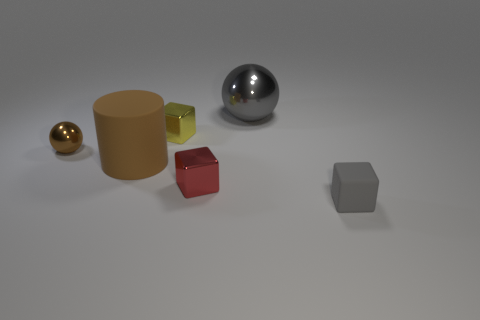How many objects are there and can you describe their colors? There are five objects in the image: a golden ball, a golden matte cylinder, a silver reflective sphere, a red cube, and a grey hexahedron. Can you tell me which object looks the most reflective? The silver sphere is the most reflective object. It acts like a mirror, reflecting the environment and highlighting its curvature with the way it catches the light. 